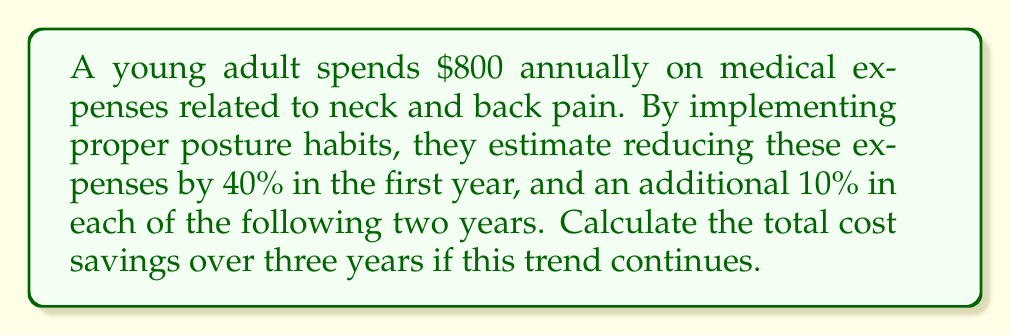Can you answer this question? Let's approach this step-by-step:

1) First year savings:
   - 40% of $800 = $800 * 0.40 = $320
   - Remaining expenses: $800 - $320 = $480

2) Second year savings:
   - Additional 10% reduction: $480 * 0.10 = $48
   - New annual expenses: $480 - $48 = $432
   - Savings in second year: $800 - $432 = $368

3) Third year savings:
   - Additional 10% reduction: $432 * 0.10 = $43.20
   - New annual expenses: $432 - $43.20 = $388.80
   - Savings in third year: $800 - $388.80 = $411.20

4) Total savings over three years:
   $$\text{Total Savings} = 320 + 368 + 411.20 = $1099.20$$
Answer: $1099.20 